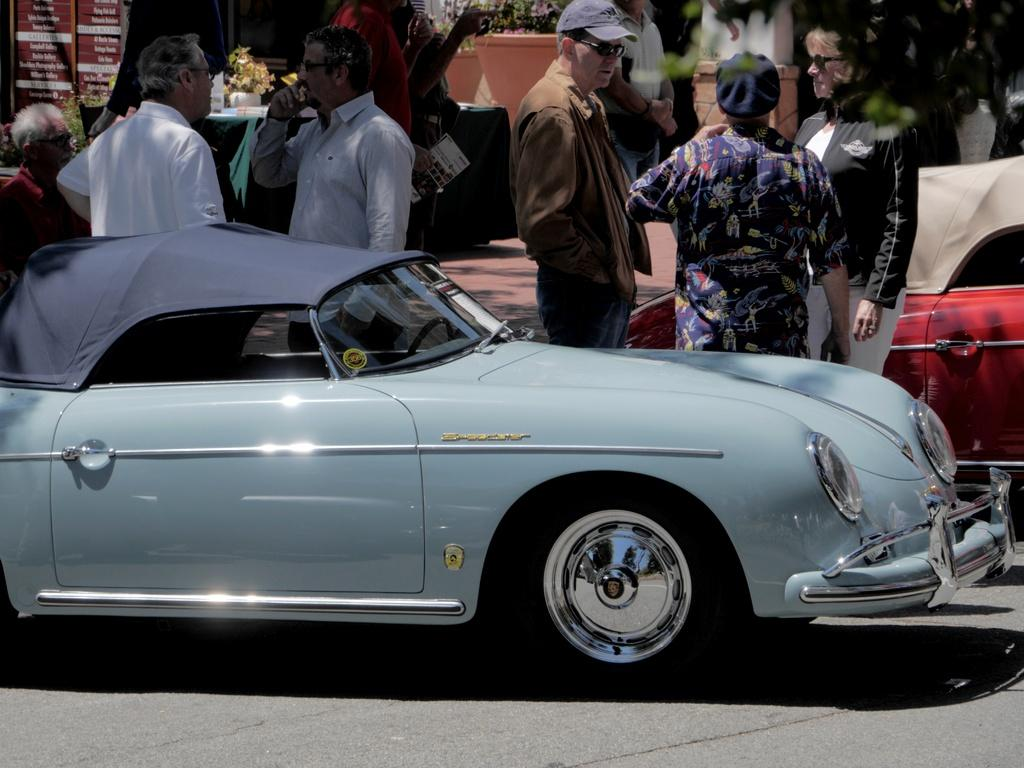Who or what is present in the image? There are people in the image. What can be seen on the road in the image? There are cars on the road in the image. What is visible in the background of the image? There are trees and plants in the background of the image. Can you describe the board in the image? Yes, there is a board in the image. Is there a cannon attacking the mountain in the image? No, there is no cannon or mountain present in the image. 